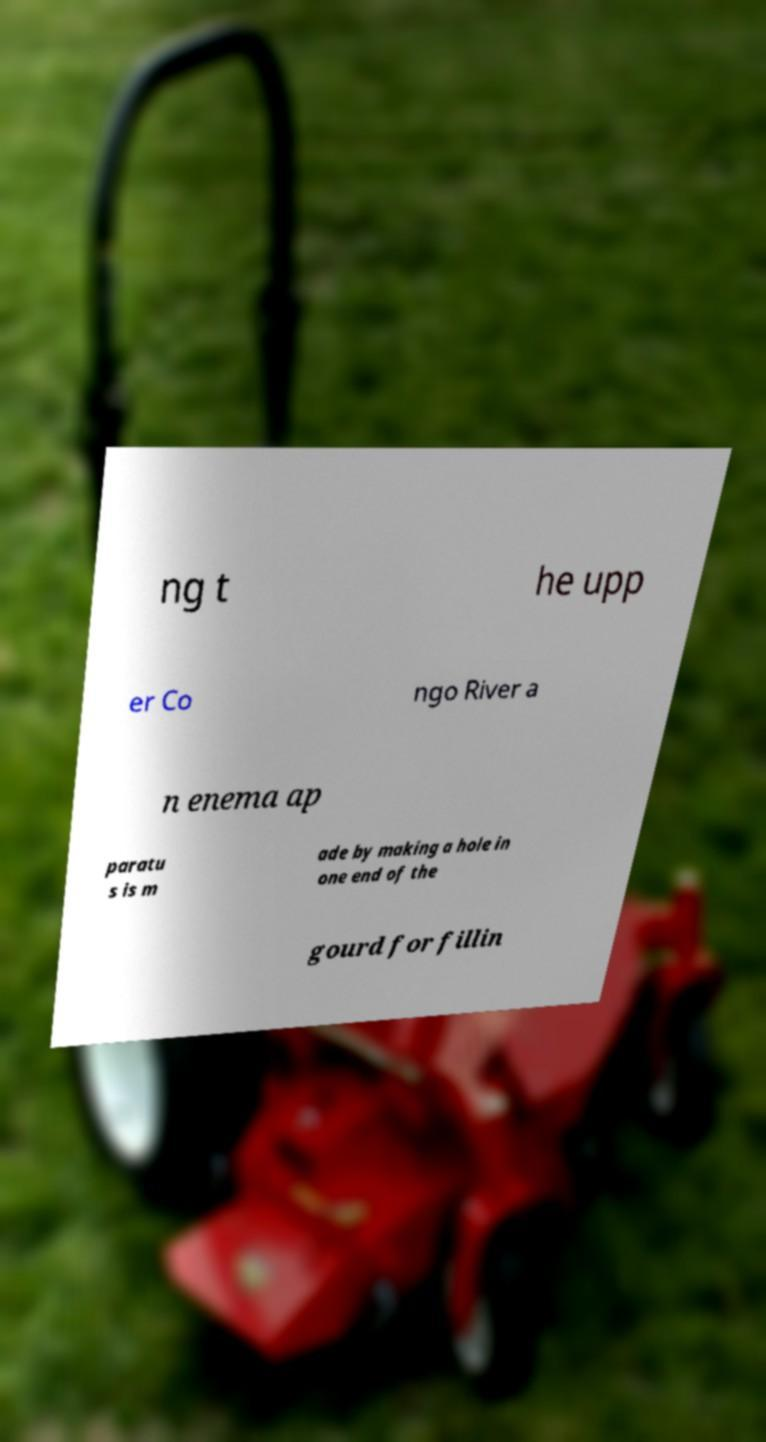There's text embedded in this image that I need extracted. Can you transcribe it verbatim? ng t he upp er Co ngo River a n enema ap paratu s is m ade by making a hole in one end of the gourd for fillin 